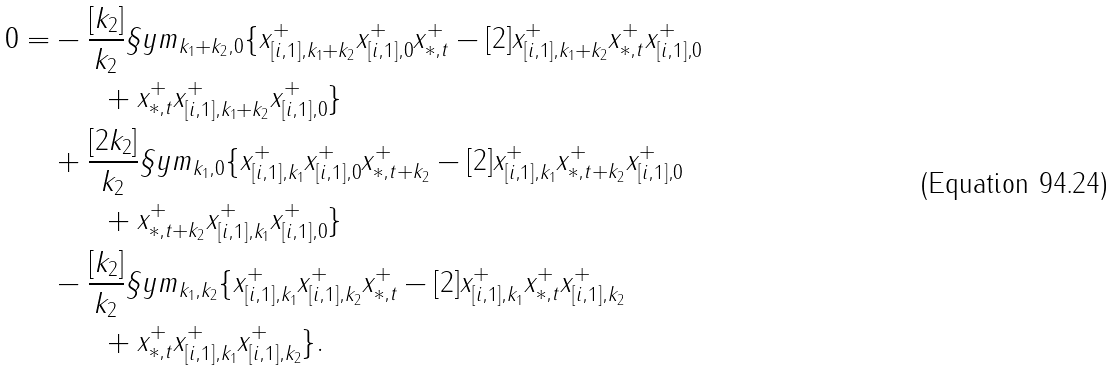Convert formula to latex. <formula><loc_0><loc_0><loc_500><loc_500>0 = & - \frac { [ k _ { 2 } ] } { k _ { 2 } } \S y m _ { k _ { 1 } + k _ { 2 } , 0 } \{ x ^ { + } _ { [ i , 1 ] , k _ { 1 } + k _ { 2 } } x ^ { + } _ { [ i , 1 ] , 0 } x ^ { + } _ { * , t } - [ 2 ] x ^ { + } _ { [ i , 1 ] , k _ { 1 } + k _ { 2 } } x ^ { + } _ { * , t } x ^ { + } _ { [ i , 1 ] , 0 } \\ & \quad \ \ + x ^ { + } _ { * , t } x ^ { + } _ { [ i , 1 ] , k _ { 1 } + k _ { 2 } } x ^ { + } _ { [ i , 1 ] , 0 } \} \\ & + \frac { [ 2 k _ { 2 } ] } { k _ { 2 } } \S y m _ { k _ { 1 } , 0 } \{ x ^ { + } _ { [ i , 1 ] , k _ { 1 } } x ^ { + } _ { [ i , 1 ] , 0 } x ^ { + } _ { * , t + k _ { 2 } } - [ 2 ] x ^ { + } _ { [ i , 1 ] , k _ { 1 } } x ^ { + } _ { * , t + k _ { 2 } } x ^ { + } _ { [ i , 1 ] , 0 } \\ & \quad \ \ + x ^ { + } _ { * , t + k _ { 2 } } x ^ { + } _ { [ i , 1 ] , k _ { 1 } } x ^ { + } _ { [ i , 1 ] , 0 } \} \\ & - \frac { [ k _ { 2 } ] } { k _ { 2 } } \S y m _ { k _ { 1 } , k _ { 2 } } \{ x ^ { + } _ { [ i , 1 ] , k _ { 1 } } x ^ { + } _ { [ i , 1 ] , k _ { 2 } } x ^ { + } _ { * , t } - [ 2 ] x ^ { + } _ { [ i , 1 ] , k _ { 1 } } x ^ { + } _ { * , t } x ^ { + } _ { [ i , 1 ] , k _ { 2 } } \\ & \quad \ \ + x ^ { + } _ { * , t } x ^ { + } _ { [ i , 1 ] , k _ { 1 } } x ^ { + } _ { [ i , 1 ] , k _ { 2 } } \} .</formula> 